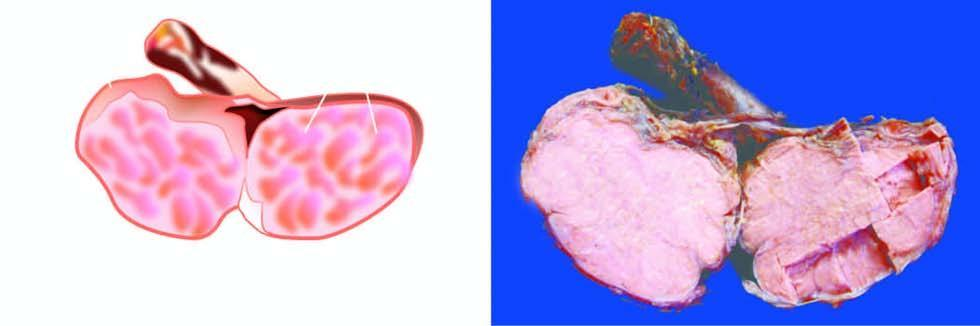the testis is enlarged but without distorting whose contour?
Answer the question using a single word or phrase. Its 